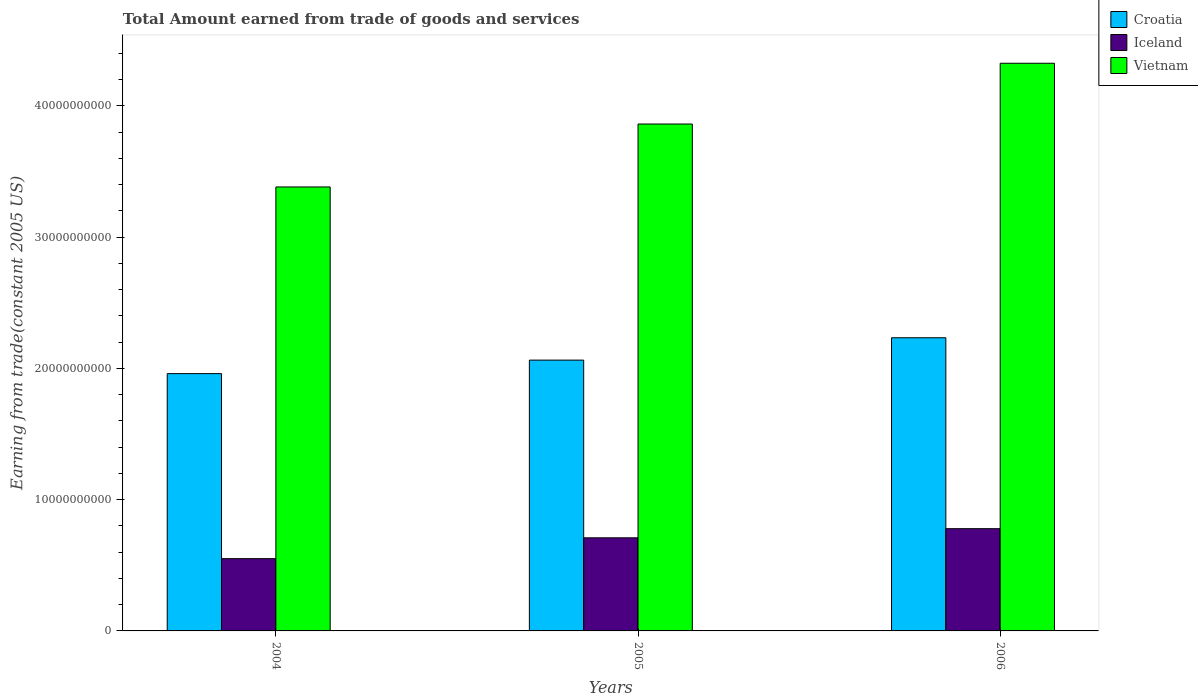How many groups of bars are there?
Your answer should be very brief. 3. Are the number of bars per tick equal to the number of legend labels?
Offer a terse response. Yes. Are the number of bars on each tick of the X-axis equal?
Your answer should be very brief. Yes. How many bars are there on the 3rd tick from the left?
Ensure brevity in your answer.  3. How many bars are there on the 2nd tick from the right?
Your answer should be compact. 3. What is the total amount earned by trading goods and services in Croatia in 2006?
Provide a succinct answer. 2.23e+1. Across all years, what is the maximum total amount earned by trading goods and services in Vietnam?
Provide a succinct answer. 4.33e+1. Across all years, what is the minimum total amount earned by trading goods and services in Iceland?
Your answer should be compact. 5.51e+09. What is the total total amount earned by trading goods and services in Iceland in the graph?
Keep it short and to the point. 2.04e+1. What is the difference between the total amount earned by trading goods and services in Iceland in 2004 and that in 2005?
Provide a short and direct response. -1.59e+09. What is the difference between the total amount earned by trading goods and services in Iceland in 2005 and the total amount earned by trading goods and services in Vietnam in 2006?
Provide a short and direct response. -3.62e+1. What is the average total amount earned by trading goods and services in Iceland per year?
Keep it short and to the point. 6.80e+09. In the year 2004, what is the difference between the total amount earned by trading goods and services in Vietnam and total amount earned by trading goods and services in Croatia?
Make the answer very short. 1.42e+1. What is the ratio of the total amount earned by trading goods and services in Vietnam in 2004 to that in 2006?
Give a very brief answer. 0.78. Is the difference between the total amount earned by trading goods and services in Vietnam in 2004 and 2006 greater than the difference between the total amount earned by trading goods and services in Croatia in 2004 and 2006?
Ensure brevity in your answer.  No. What is the difference between the highest and the second highest total amount earned by trading goods and services in Iceland?
Ensure brevity in your answer.  6.97e+08. What is the difference between the highest and the lowest total amount earned by trading goods and services in Iceland?
Your answer should be compact. 2.28e+09. Is the sum of the total amount earned by trading goods and services in Vietnam in 2005 and 2006 greater than the maximum total amount earned by trading goods and services in Croatia across all years?
Your response must be concise. Yes. What does the 3rd bar from the left in 2004 represents?
Your answer should be compact. Vietnam. What does the 2nd bar from the right in 2006 represents?
Provide a succinct answer. Iceland. Is it the case that in every year, the sum of the total amount earned by trading goods and services in Croatia and total amount earned by trading goods and services in Vietnam is greater than the total amount earned by trading goods and services in Iceland?
Your response must be concise. Yes. How many years are there in the graph?
Your answer should be very brief. 3. Are the values on the major ticks of Y-axis written in scientific E-notation?
Give a very brief answer. No. Where does the legend appear in the graph?
Your answer should be compact. Top right. How are the legend labels stacked?
Keep it short and to the point. Vertical. What is the title of the graph?
Ensure brevity in your answer.  Total Amount earned from trade of goods and services. What is the label or title of the X-axis?
Your answer should be compact. Years. What is the label or title of the Y-axis?
Provide a short and direct response. Earning from trade(constant 2005 US). What is the Earning from trade(constant 2005 US) of Croatia in 2004?
Keep it short and to the point. 1.96e+1. What is the Earning from trade(constant 2005 US) of Iceland in 2004?
Your answer should be compact. 5.51e+09. What is the Earning from trade(constant 2005 US) of Vietnam in 2004?
Your response must be concise. 3.38e+1. What is the Earning from trade(constant 2005 US) of Croatia in 2005?
Ensure brevity in your answer.  2.06e+1. What is the Earning from trade(constant 2005 US) of Iceland in 2005?
Give a very brief answer. 7.09e+09. What is the Earning from trade(constant 2005 US) in Vietnam in 2005?
Provide a short and direct response. 3.86e+1. What is the Earning from trade(constant 2005 US) of Croatia in 2006?
Offer a very short reply. 2.23e+1. What is the Earning from trade(constant 2005 US) of Iceland in 2006?
Give a very brief answer. 7.79e+09. What is the Earning from trade(constant 2005 US) in Vietnam in 2006?
Your answer should be compact. 4.33e+1. Across all years, what is the maximum Earning from trade(constant 2005 US) of Croatia?
Ensure brevity in your answer.  2.23e+1. Across all years, what is the maximum Earning from trade(constant 2005 US) of Iceland?
Ensure brevity in your answer.  7.79e+09. Across all years, what is the maximum Earning from trade(constant 2005 US) of Vietnam?
Make the answer very short. 4.33e+1. Across all years, what is the minimum Earning from trade(constant 2005 US) of Croatia?
Provide a succinct answer. 1.96e+1. Across all years, what is the minimum Earning from trade(constant 2005 US) of Iceland?
Keep it short and to the point. 5.51e+09. Across all years, what is the minimum Earning from trade(constant 2005 US) of Vietnam?
Give a very brief answer. 3.38e+1. What is the total Earning from trade(constant 2005 US) of Croatia in the graph?
Offer a terse response. 6.26e+1. What is the total Earning from trade(constant 2005 US) of Iceland in the graph?
Make the answer very short. 2.04e+1. What is the total Earning from trade(constant 2005 US) of Vietnam in the graph?
Offer a terse response. 1.16e+11. What is the difference between the Earning from trade(constant 2005 US) of Croatia in 2004 and that in 2005?
Your response must be concise. -1.03e+09. What is the difference between the Earning from trade(constant 2005 US) of Iceland in 2004 and that in 2005?
Your response must be concise. -1.59e+09. What is the difference between the Earning from trade(constant 2005 US) in Vietnam in 2004 and that in 2005?
Your response must be concise. -4.80e+09. What is the difference between the Earning from trade(constant 2005 US) of Croatia in 2004 and that in 2006?
Offer a terse response. -2.73e+09. What is the difference between the Earning from trade(constant 2005 US) of Iceland in 2004 and that in 2006?
Offer a terse response. -2.28e+09. What is the difference between the Earning from trade(constant 2005 US) in Vietnam in 2004 and that in 2006?
Your answer should be compact. -9.43e+09. What is the difference between the Earning from trade(constant 2005 US) of Croatia in 2005 and that in 2006?
Your answer should be very brief. -1.70e+09. What is the difference between the Earning from trade(constant 2005 US) in Iceland in 2005 and that in 2006?
Your answer should be compact. -6.97e+08. What is the difference between the Earning from trade(constant 2005 US) in Vietnam in 2005 and that in 2006?
Your response must be concise. -4.63e+09. What is the difference between the Earning from trade(constant 2005 US) in Croatia in 2004 and the Earning from trade(constant 2005 US) in Iceland in 2005?
Ensure brevity in your answer.  1.25e+1. What is the difference between the Earning from trade(constant 2005 US) of Croatia in 2004 and the Earning from trade(constant 2005 US) of Vietnam in 2005?
Make the answer very short. -1.90e+1. What is the difference between the Earning from trade(constant 2005 US) of Iceland in 2004 and the Earning from trade(constant 2005 US) of Vietnam in 2005?
Provide a succinct answer. -3.31e+1. What is the difference between the Earning from trade(constant 2005 US) of Croatia in 2004 and the Earning from trade(constant 2005 US) of Iceland in 2006?
Your response must be concise. 1.18e+1. What is the difference between the Earning from trade(constant 2005 US) in Croatia in 2004 and the Earning from trade(constant 2005 US) in Vietnam in 2006?
Provide a succinct answer. -2.36e+1. What is the difference between the Earning from trade(constant 2005 US) of Iceland in 2004 and the Earning from trade(constant 2005 US) of Vietnam in 2006?
Your response must be concise. -3.77e+1. What is the difference between the Earning from trade(constant 2005 US) of Croatia in 2005 and the Earning from trade(constant 2005 US) of Iceland in 2006?
Your answer should be compact. 1.28e+1. What is the difference between the Earning from trade(constant 2005 US) in Croatia in 2005 and the Earning from trade(constant 2005 US) in Vietnam in 2006?
Provide a succinct answer. -2.26e+1. What is the difference between the Earning from trade(constant 2005 US) of Iceland in 2005 and the Earning from trade(constant 2005 US) of Vietnam in 2006?
Your answer should be compact. -3.62e+1. What is the average Earning from trade(constant 2005 US) of Croatia per year?
Your response must be concise. 2.09e+1. What is the average Earning from trade(constant 2005 US) of Iceland per year?
Your response must be concise. 6.80e+09. What is the average Earning from trade(constant 2005 US) in Vietnam per year?
Offer a terse response. 3.86e+1. In the year 2004, what is the difference between the Earning from trade(constant 2005 US) of Croatia and Earning from trade(constant 2005 US) of Iceland?
Keep it short and to the point. 1.41e+1. In the year 2004, what is the difference between the Earning from trade(constant 2005 US) of Croatia and Earning from trade(constant 2005 US) of Vietnam?
Provide a short and direct response. -1.42e+1. In the year 2004, what is the difference between the Earning from trade(constant 2005 US) of Iceland and Earning from trade(constant 2005 US) of Vietnam?
Make the answer very short. -2.83e+1. In the year 2005, what is the difference between the Earning from trade(constant 2005 US) of Croatia and Earning from trade(constant 2005 US) of Iceland?
Your response must be concise. 1.35e+1. In the year 2005, what is the difference between the Earning from trade(constant 2005 US) in Croatia and Earning from trade(constant 2005 US) in Vietnam?
Your answer should be compact. -1.80e+1. In the year 2005, what is the difference between the Earning from trade(constant 2005 US) of Iceland and Earning from trade(constant 2005 US) of Vietnam?
Your answer should be compact. -3.15e+1. In the year 2006, what is the difference between the Earning from trade(constant 2005 US) in Croatia and Earning from trade(constant 2005 US) in Iceland?
Provide a succinct answer. 1.45e+1. In the year 2006, what is the difference between the Earning from trade(constant 2005 US) of Croatia and Earning from trade(constant 2005 US) of Vietnam?
Your response must be concise. -2.09e+1. In the year 2006, what is the difference between the Earning from trade(constant 2005 US) in Iceland and Earning from trade(constant 2005 US) in Vietnam?
Your answer should be very brief. -3.55e+1. What is the ratio of the Earning from trade(constant 2005 US) of Croatia in 2004 to that in 2005?
Your answer should be very brief. 0.95. What is the ratio of the Earning from trade(constant 2005 US) of Iceland in 2004 to that in 2005?
Offer a very short reply. 0.78. What is the ratio of the Earning from trade(constant 2005 US) of Vietnam in 2004 to that in 2005?
Your answer should be compact. 0.88. What is the ratio of the Earning from trade(constant 2005 US) in Croatia in 2004 to that in 2006?
Provide a succinct answer. 0.88. What is the ratio of the Earning from trade(constant 2005 US) of Iceland in 2004 to that in 2006?
Offer a very short reply. 0.71. What is the ratio of the Earning from trade(constant 2005 US) of Vietnam in 2004 to that in 2006?
Your answer should be very brief. 0.78. What is the ratio of the Earning from trade(constant 2005 US) in Croatia in 2005 to that in 2006?
Ensure brevity in your answer.  0.92. What is the ratio of the Earning from trade(constant 2005 US) in Iceland in 2005 to that in 2006?
Ensure brevity in your answer.  0.91. What is the ratio of the Earning from trade(constant 2005 US) in Vietnam in 2005 to that in 2006?
Give a very brief answer. 0.89. What is the difference between the highest and the second highest Earning from trade(constant 2005 US) in Croatia?
Your answer should be compact. 1.70e+09. What is the difference between the highest and the second highest Earning from trade(constant 2005 US) in Iceland?
Your answer should be compact. 6.97e+08. What is the difference between the highest and the second highest Earning from trade(constant 2005 US) of Vietnam?
Make the answer very short. 4.63e+09. What is the difference between the highest and the lowest Earning from trade(constant 2005 US) in Croatia?
Your answer should be very brief. 2.73e+09. What is the difference between the highest and the lowest Earning from trade(constant 2005 US) in Iceland?
Give a very brief answer. 2.28e+09. What is the difference between the highest and the lowest Earning from trade(constant 2005 US) of Vietnam?
Your answer should be very brief. 9.43e+09. 